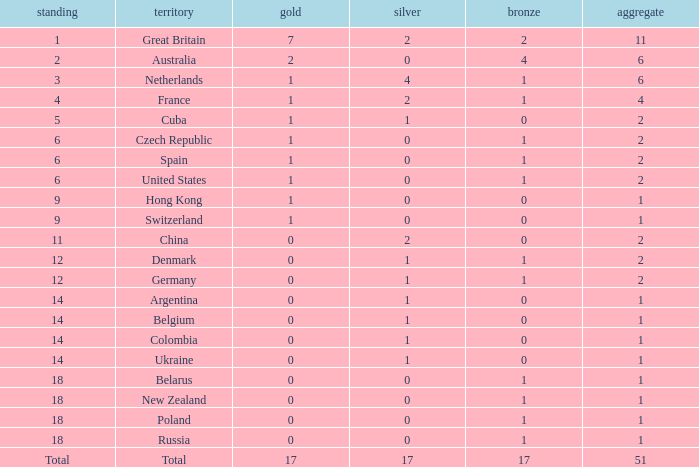Tell me the lowest gold for rank of 6 and total less than 2 None. 